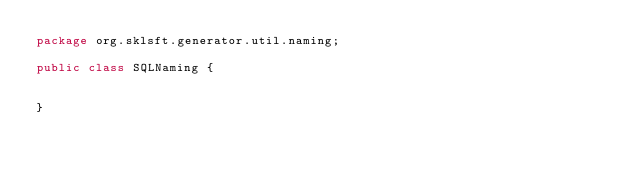<code> <loc_0><loc_0><loc_500><loc_500><_Java_>package org.sklsft.generator.util.naming;

public class SQLNaming {
	
	
}
</code> 